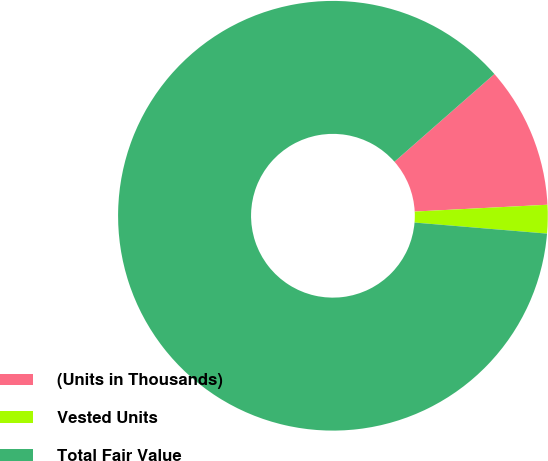Convert chart. <chart><loc_0><loc_0><loc_500><loc_500><pie_chart><fcel>(Units in Thousands)<fcel>Vested Units<fcel>Total Fair Value<nl><fcel>10.65%<fcel>2.14%<fcel>87.21%<nl></chart> 